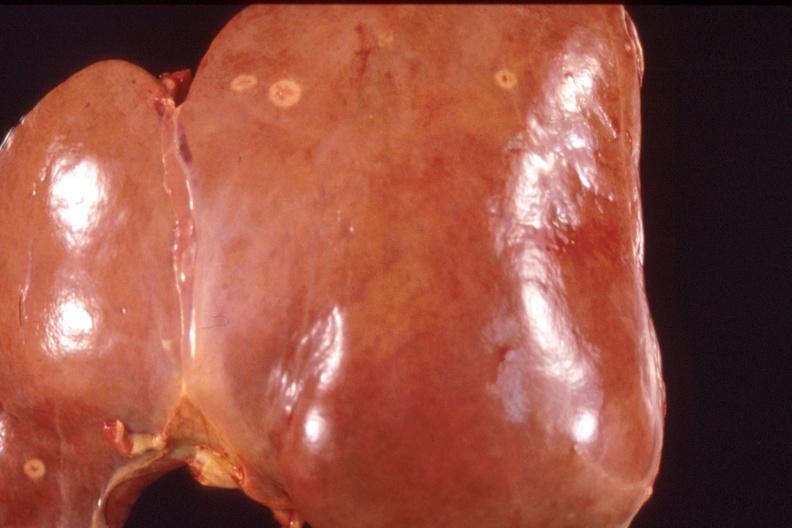s hepatobiliary present?
Answer the question using a single word or phrase. Yes 